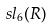<formula> <loc_0><loc_0><loc_500><loc_500>s l _ { 6 } ( R )</formula> 